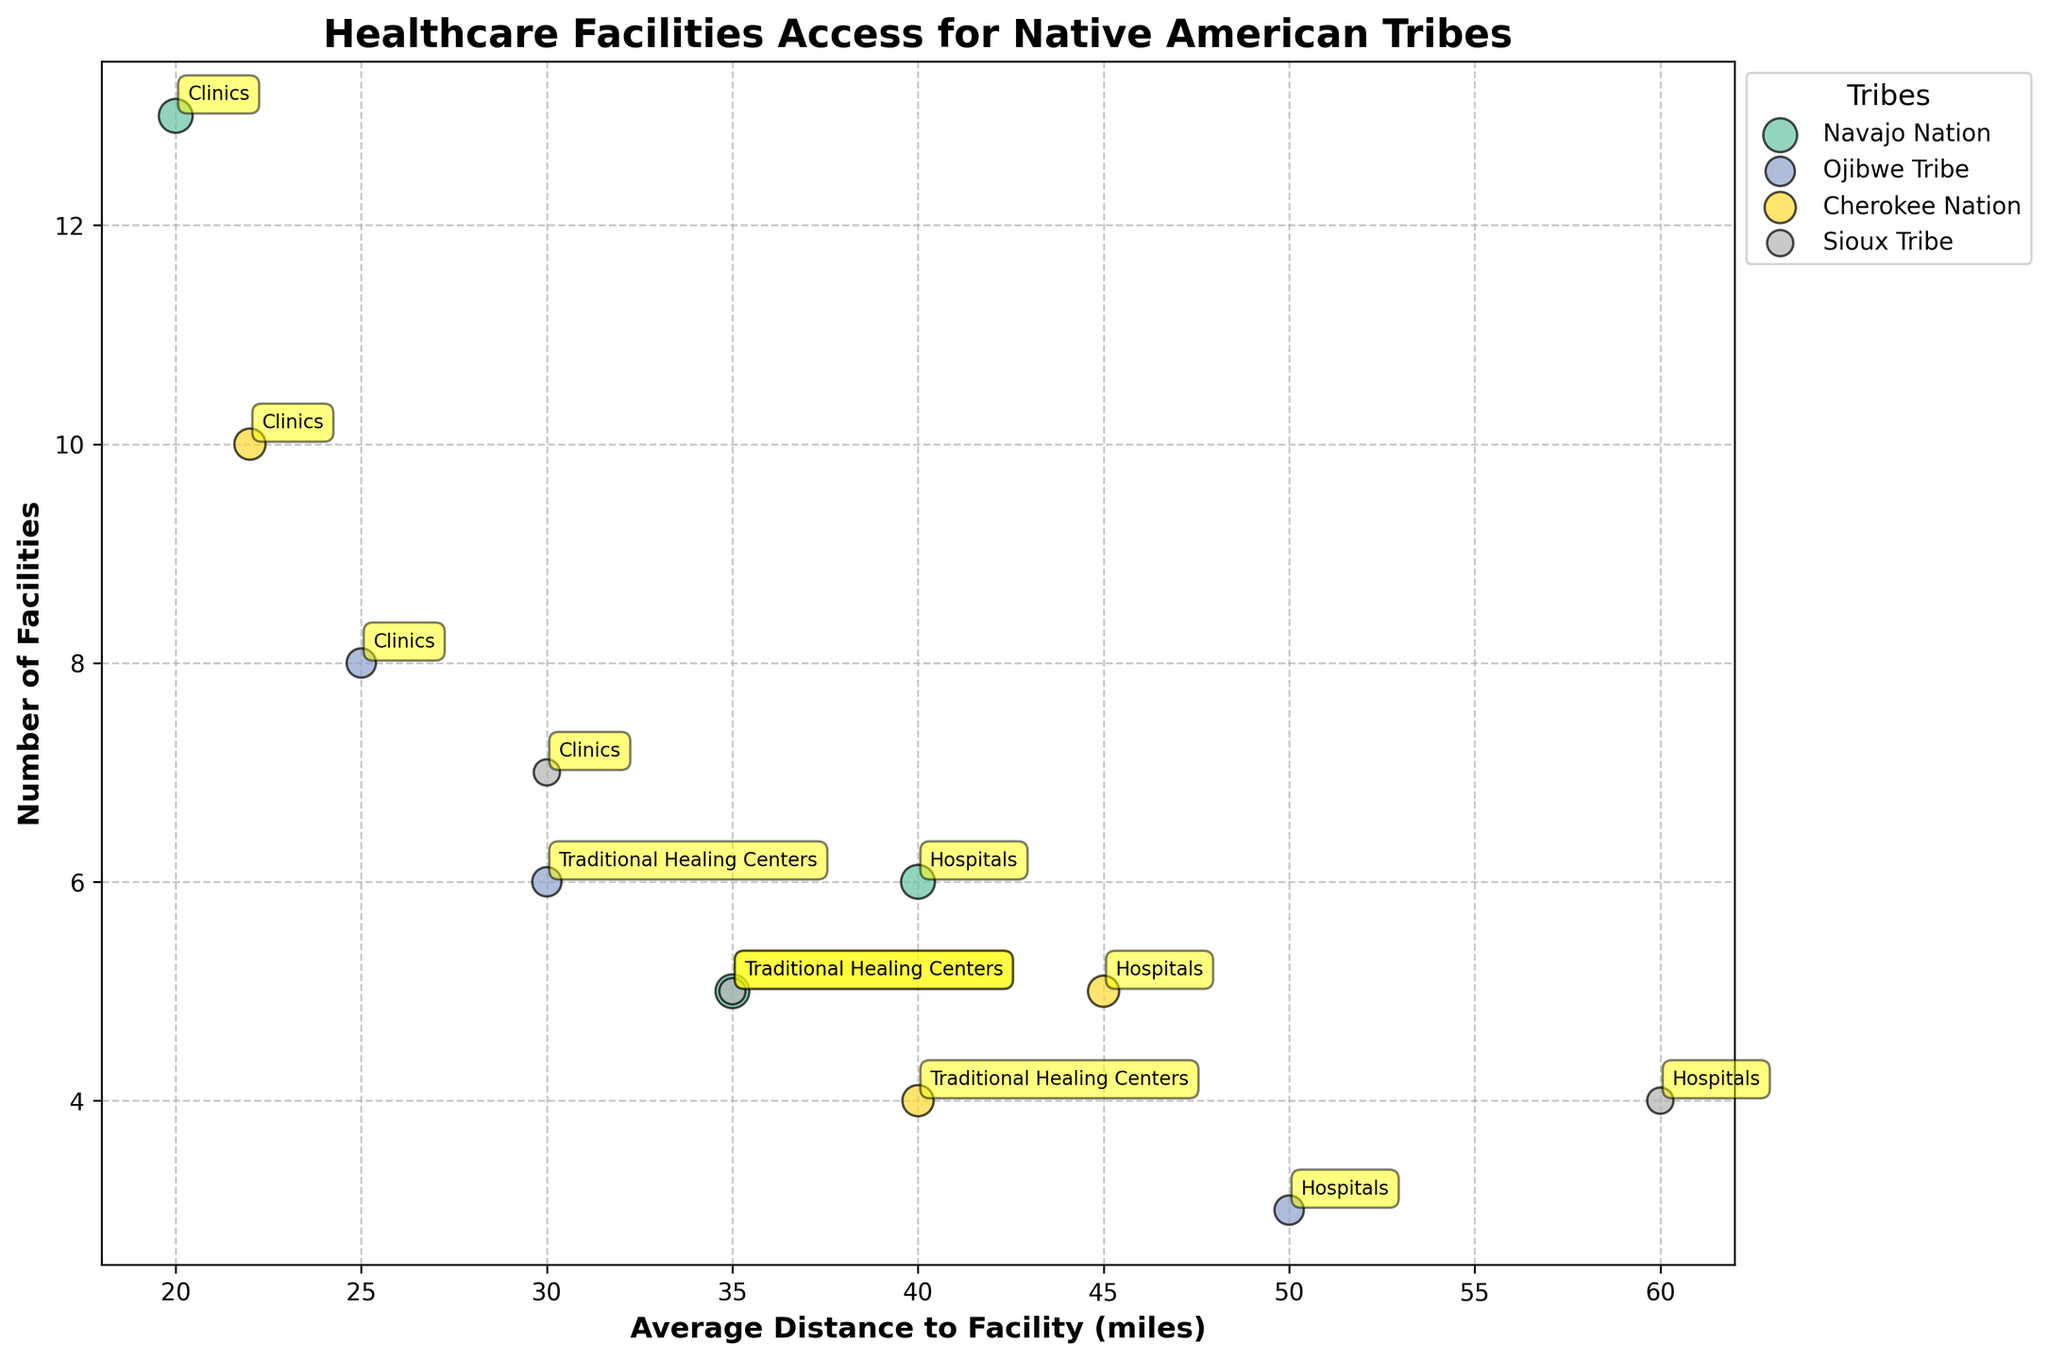what is the title of the figure? The title of the figure is displayed at the top of the chart.
Answer: Healthcare Facilities Access for Native American Tribes What is the label for the x-axis? The label for the x-axis can be found on the horizontal axis.
Answer: Average Distance to Facility (miles) Which tribe has the highest number of hospital facilities? By locating the points on the vertical axis labeled "Hospitals," we can compare the number of facilities for each tribe.
Answer: Navajo Nation Which healthcare facility type serves the largest population size for the Cherokee Nation? Use the size of the bubbles representing different facility types for the Cherokee Nation to determine which one is the largest.
Answer: Clinics Which tribe has the clinic facilities closest to the population? Compare the average distances of clinic facilities for each tribe by looking at the horizontal axis values.
Answer: Navajo Nation How many facilities are in total for the Ojibwe Tribe? Add the number of hospital, clinic, and traditional healing centers for the Ojibwe Tribe. 3 + 8 + 6 = 17
Answer: 17 Which tribe has the furthest average distance to hospitals, and what is that distance? Look for the hospital bubbles and check the horizontal axis values for each tribe.
Answer: Sioux Tribe, 60 miles What is the difference in the number of clinic facilities between the smallest and largest tribes in terms of population served? Compare the number of clinics between the tribe with the smallest population (Sioux Tribe) and the largest population (Navajo Nation). 13 - 7 = 6
Answer: 6 Which healthcare facility type in the Sioux Tribe is furthest from the population, and what is the distance? Compare the average distances for different facility types within the Sioux Tribe using the horizontal axis values.
Answer: Hospitals, 60 miles 